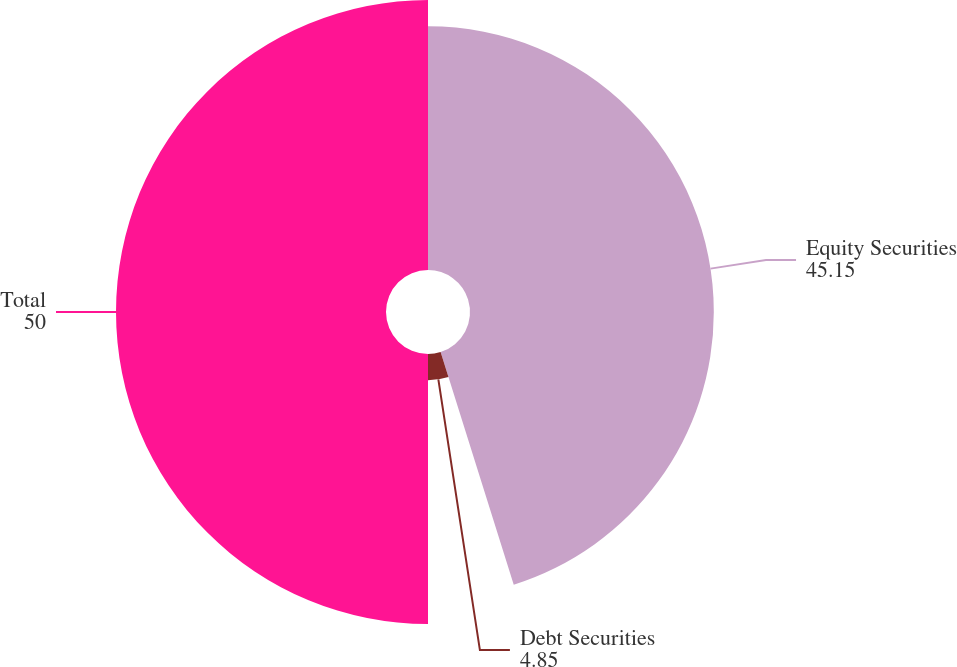<chart> <loc_0><loc_0><loc_500><loc_500><pie_chart><fcel>Equity Securities<fcel>Debt Securities<fcel>Total<nl><fcel>45.15%<fcel>4.85%<fcel>50.0%<nl></chart> 